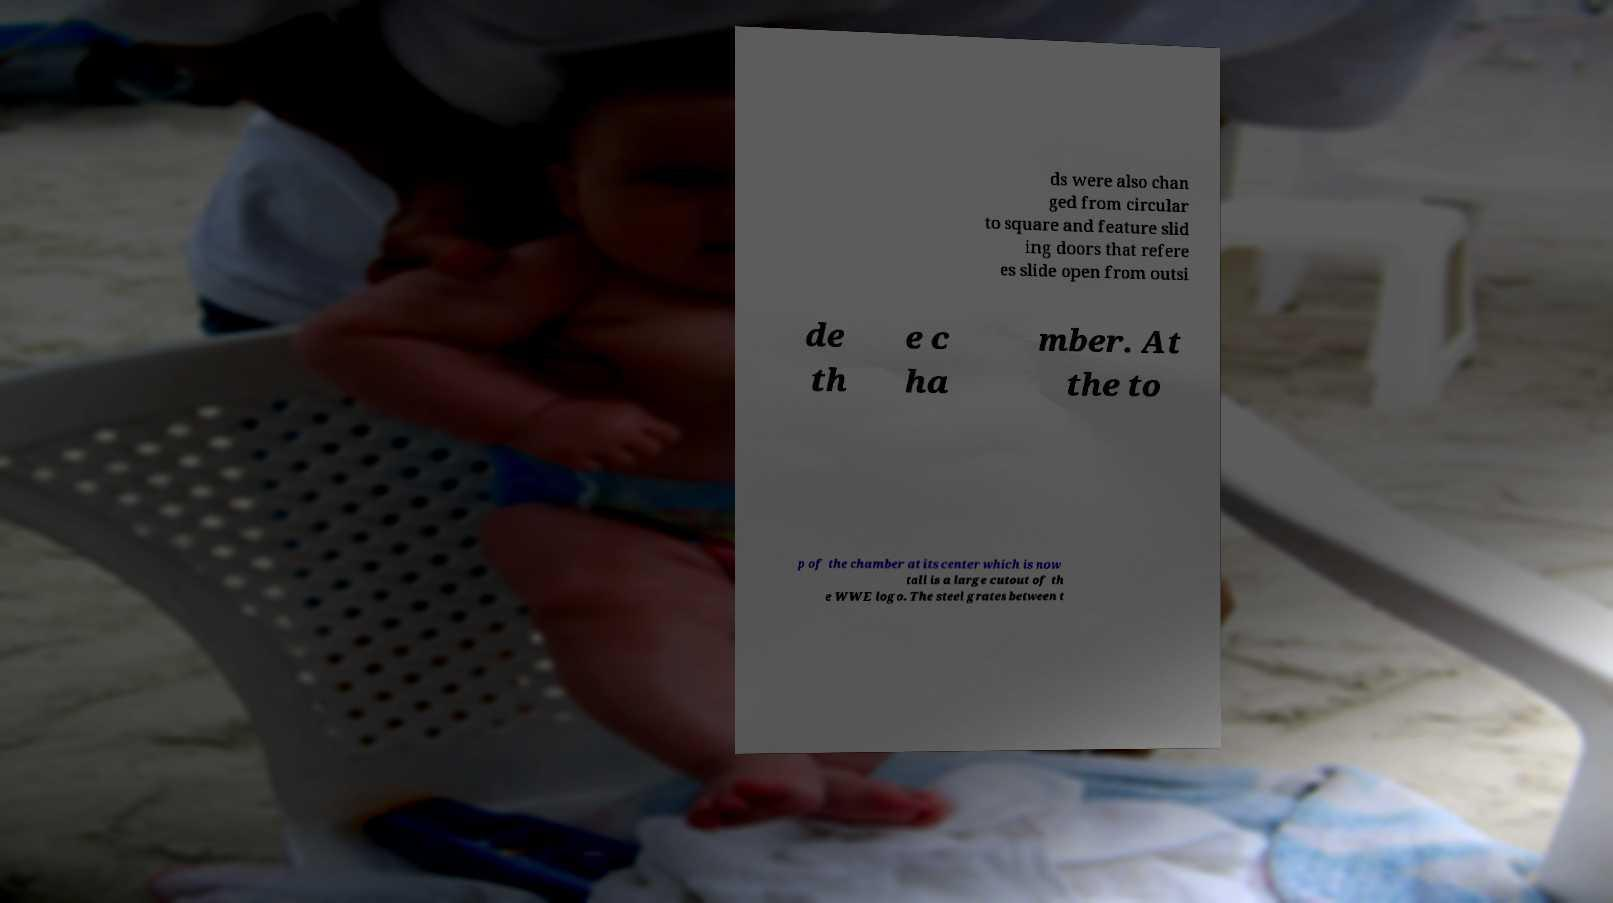Please read and relay the text visible in this image. What does it say? ds were also chan ged from circular to square and feature slid ing doors that refere es slide open from outsi de th e c ha mber. At the to p of the chamber at its center which is now tall is a large cutout of th e WWE logo. The steel grates between t 